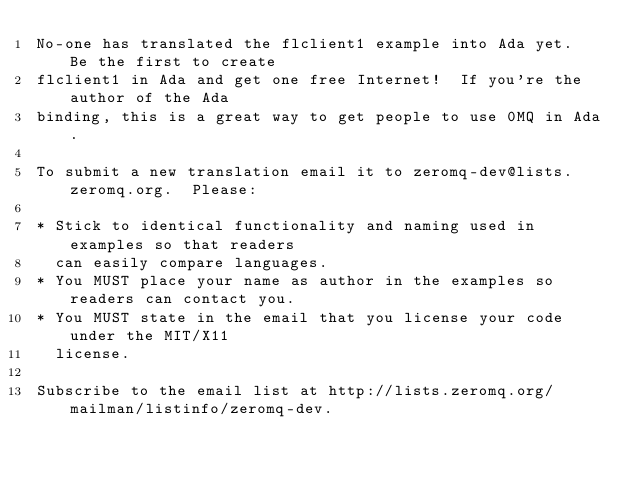<code> <loc_0><loc_0><loc_500><loc_500><_Ada_>No-one has translated the flclient1 example into Ada yet.  Be the first to create
flclient1 in Ada and get one free Internet!  If you're the author of the Ada
binding, this is a great way to get people to use 0MQ in Ada.

To submit a new translation email it to zeromq-dev@lists.zeromq.org.  Please:

* Stick to identical functionality and naming used in examples so that readers
  can easily compare languages.
* You MUST place your name as author in the examples so readers can contact you.
* You MUST state in the email that you license your code under the MIT/X11
  license.

Subscribe to the email list at http://lists.zeromq.org/mailman/listinfo/zeromq-dev.
</code> 